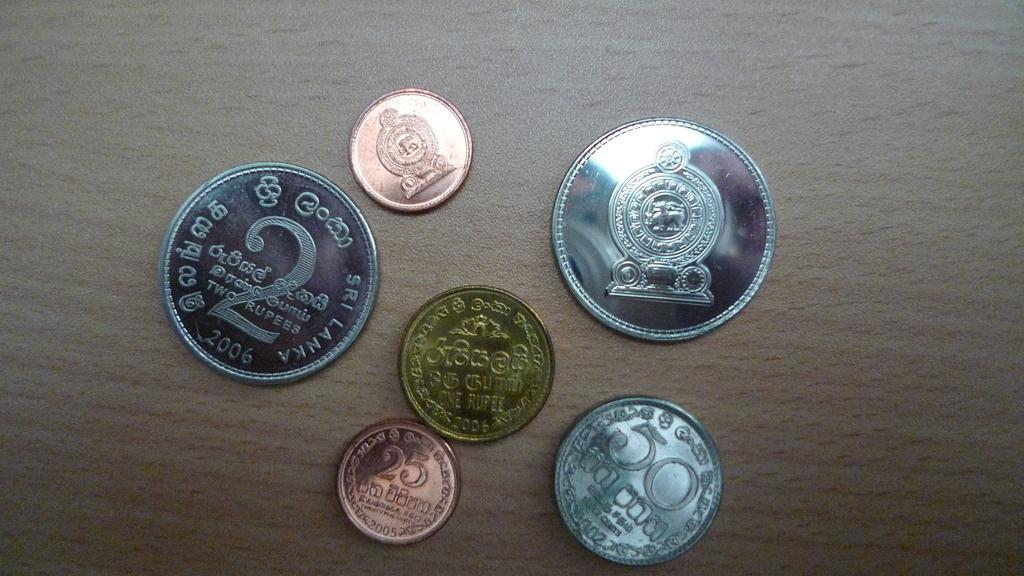<image>
Describe the image concisely. A coin with the number 2 very large on it sits next to 5 other coins. 